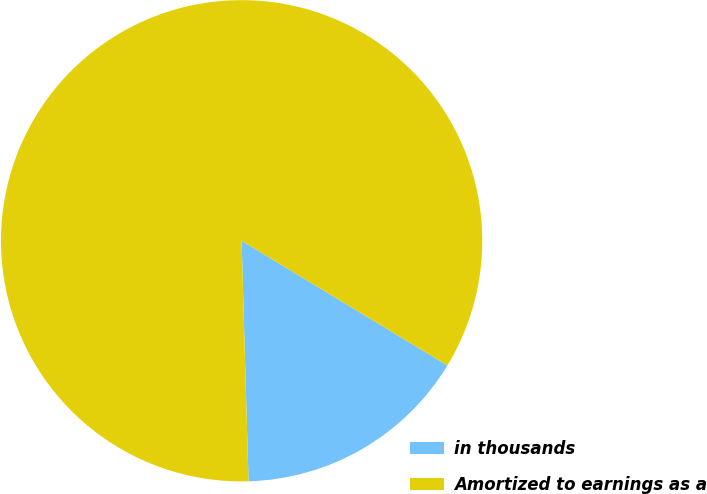<chart> <loc_0><loc_0><loc_500><loc_500><pie_chart><fcel>in thousands<fcel>Amortized to earnings as a<nl><fcel>15.87%<fcel>84.13%<nl></chart> 